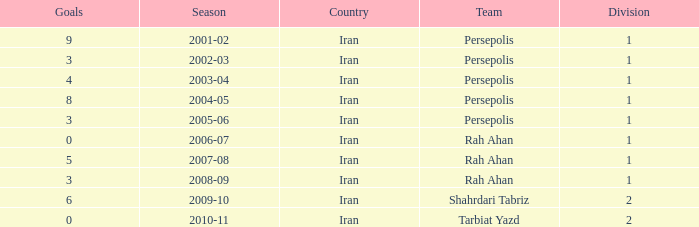What is the sum of Goals, when Season is "2005-06", and when Division is less than 1? None. 